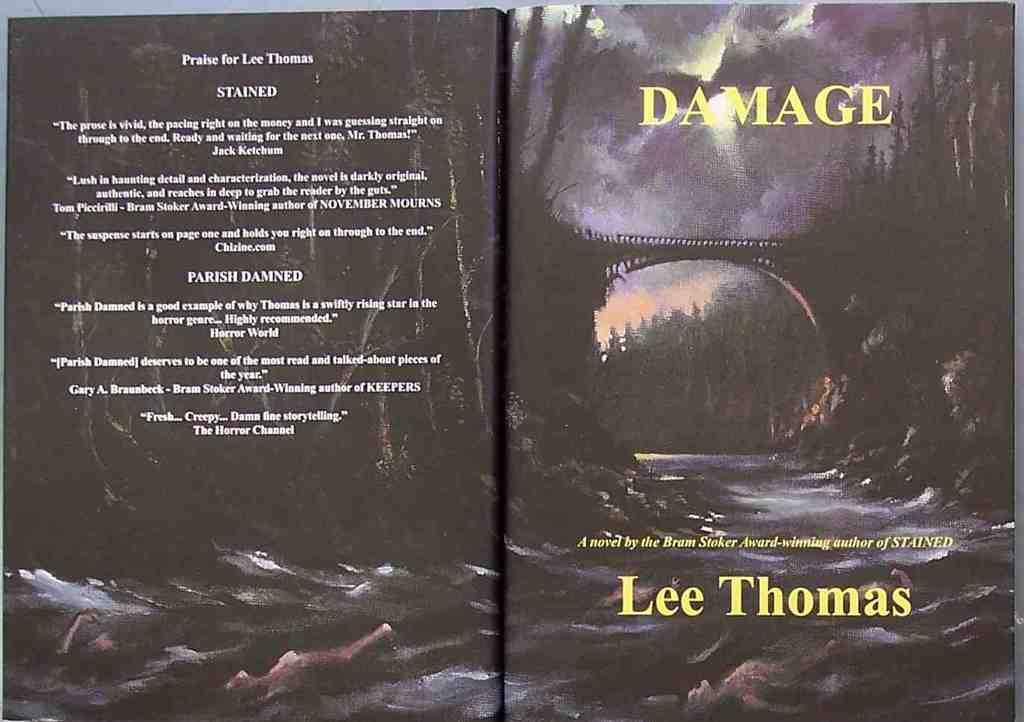<image>
Create a compact narrative representing the image presented. A book titled Damage by lee Thomas features a spooky cover of a bridge and river during a storm 